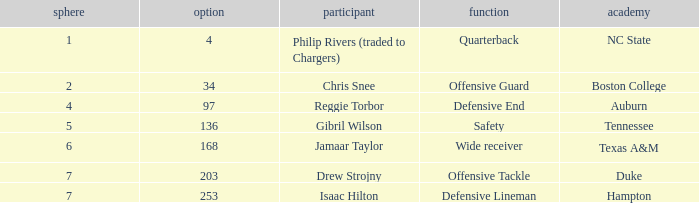Which Position has a Round larger than 5, and a Selection of 168? Wide receiver. 